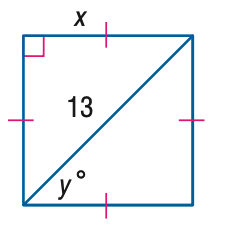Answer the mathemtical geometry problem and directly provide the correct option letter.
Question: Find x.
Choices: A: \frac { 13 } { 2 } B: \frac { 13 \sqrt { 2 } } { 2 } C: \frac { 13 \sqrt { 3 } } { 2 } D: 13 \sqrt { 2 } B 